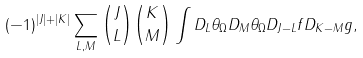<formula> <loc_0><loc_0><loc_500><loc_500>( - 1 ) ^ { | J | + | K | } \sum _ { L , M } { J \choose L } { K \choose M } \int D _ { L } \theta _ { \Omega } D _ { M } \theta _ { \Omega } D _ { J - L } f D _ { K - M } g ,</formula> 